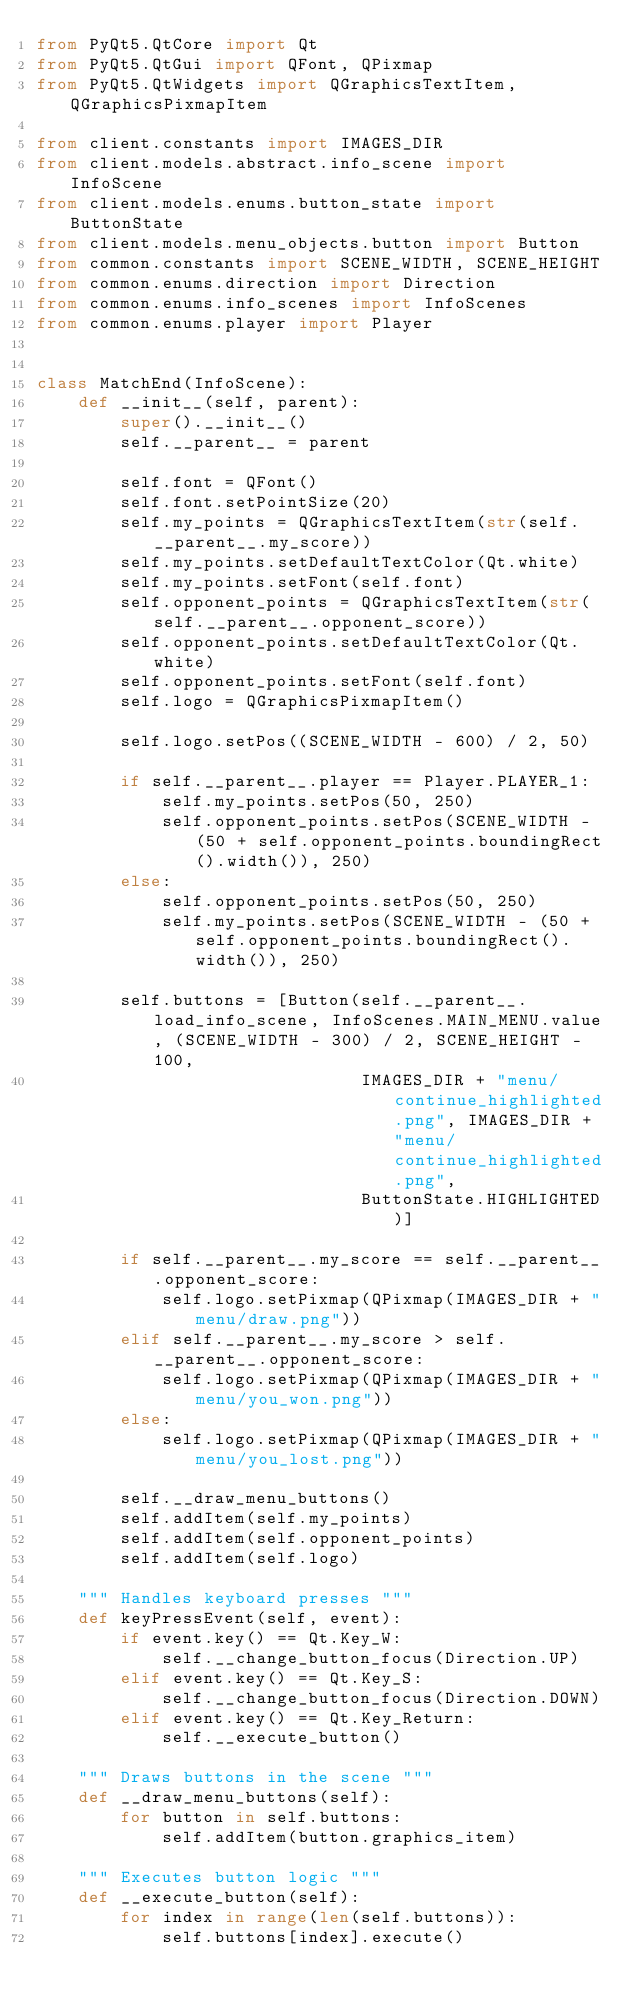Convert code to text. <code><loc_0><loc_0><loc_500><loc_500><_Python_>from PyQt5.QtCore import Qt
from PyQt5.QtGui import QFont, QPixmap
from PyQt5.QtWidgets import QGraphicsTextItem, QGraphicsPixmapItem

from client.constants import IMAGES_DIR
from client.models.abstract.info_scene import InfoScene
from client.models.enums.button_state import ButtonState
from client.models.menu_objects.button import Button
from common.constants import SCENE_WIDTH, SCENE_HEIGHT
from common.enums.direction import Direction
from common.enums.info_scenes import InfoScenes
from common.enums.player import Player


class MatchEnd(InfoScene):
    def __init__(self, parent):
        super().__init__()
        self.__parent__ = parent

        self.font = QFont()
        self.font.setPointSize(20)
        self.my_points = QGraphicsTextItem(str(self.__parent__.my_score))
        self.my_points.setDefaultTextColor(Qt.white)
        self.my_points.setFont(self.font)
        self.opponent_points = QGraphicsTextItem(str(self.__parent__.opponent_score))
        self.opponent_points.setDefaultTextColor(Qt.white)
        self.opponent_points.setFont(self.font)
        self.logo = QGraphicsPixmapItem()

        self.logo.setPos((SCENE_WIDTH - 600) / 2, 50)

        if self.__parent__.player == Player.PLAYER_1:
            self.my_points.setPos(50, 250)
            self.opponent_points.setPos(SCENE_WIDTH - (50 + self.opponent_points.boundingRect().width()), 250)
        else:
            self.opponent_points.setPos(50, 250)
            self.my_points.setPos(SCENE_WIDTH - (50 + self.opponent_points.boundingRect().width()), 250)

        self.buttons = [Button(self.__parent__.load_info_scene, InfoScenes.MAIN_MENU.value, (SCENE_WIDTH - 300) / 2, SCENE_HEIGHT - 100,
                               IMAGES_DIR + "menu/continue_highlighted.png", IMAGES_DIR + "menu/continue_highlighted.png",
                               ButtonState.HIGHLIGHTED)]

        if self.__parent__.my_score == self.__parent__.opponent_score:
            self.logo.setPixmap(QPixmap(IMAGES_DIR + "menu/draw.png"))
        elif self.__parent__.my_score > self.__parent__.opponent_score:
            self.logo.setPixmap(QPixmap(IMAGES_DIR + "menu/you_won.png"))
        else:
            self.logo.setPixmap(QPixmap(IMAGES_DIR + "menu/you_lost.png"))

        self.__draw_menu_buttons()
        self.addItem(self.my_points)
        self.addItem(self.opponent_points)
        self.addItem(self.logo)

    """ Handles keyboard presses """
    def keyPressEvent(self, event):
        if event.key() == Qt.Key_W:
            self.__change_button_focus(Direction.UP)
        elif event.key() == Qt.Key_S:
            self.__change_button_focus(Direction.DOWN)
        elif event.key() == Qt.Key_Return:
            self.__execute_button()

    """ Draws buttons in the scene """
    def __draw_menu_buttons(self):
        for button in self.buttons:
            self.addItem(button.graphics_item)

    """ Executes button logic """
    def __execute_button(self):
        for index in range(len(self.buttons)):
            self.buttons[index].execute()
</code> 